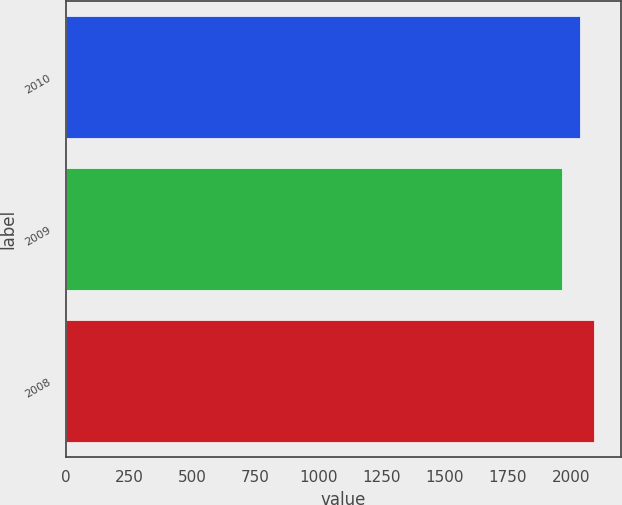<chart> <loc_0><loc_0><loc_500><loc_500><bar_chart><fcel>2010<fcel>2009<fcel>2008<nl><fcel>2035<fcel>1965<fcel>2093<nl></chart> 